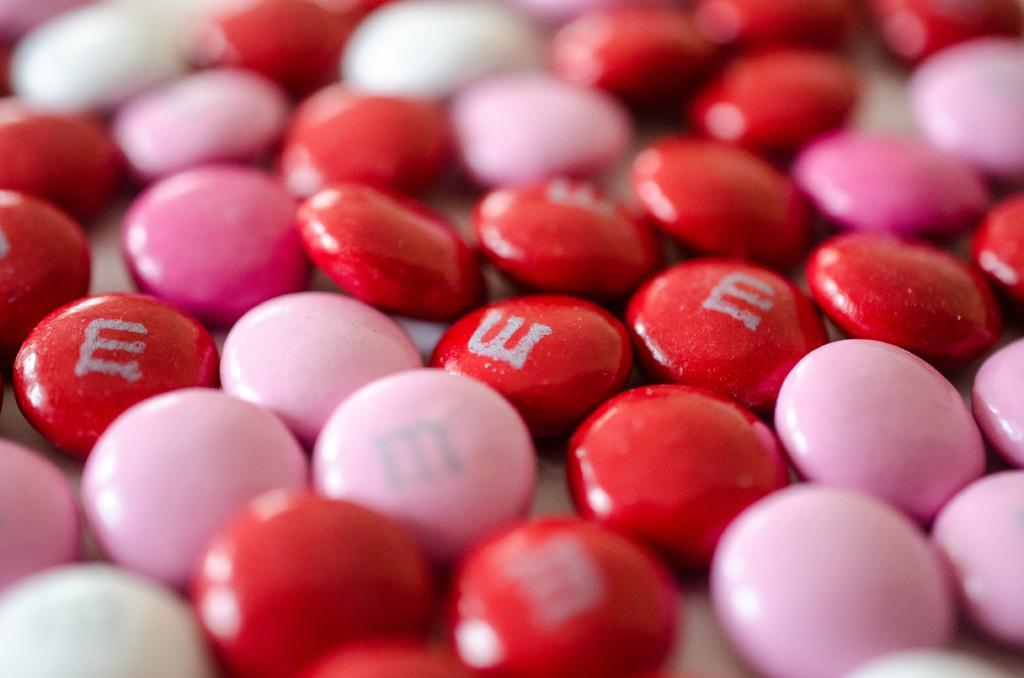What type of organisms are present in the image? There are germs in the image. What colors are the germs in the image? The germs are in red, pink, and white colors. Are there any distinguishing features on the germs? Yes, the letter "E" is written on the red germs. What type of scarecrow can be seen in the image? There is no scarecrow present in the image; it features germs in various colors with a letter "E" on the red germs. 